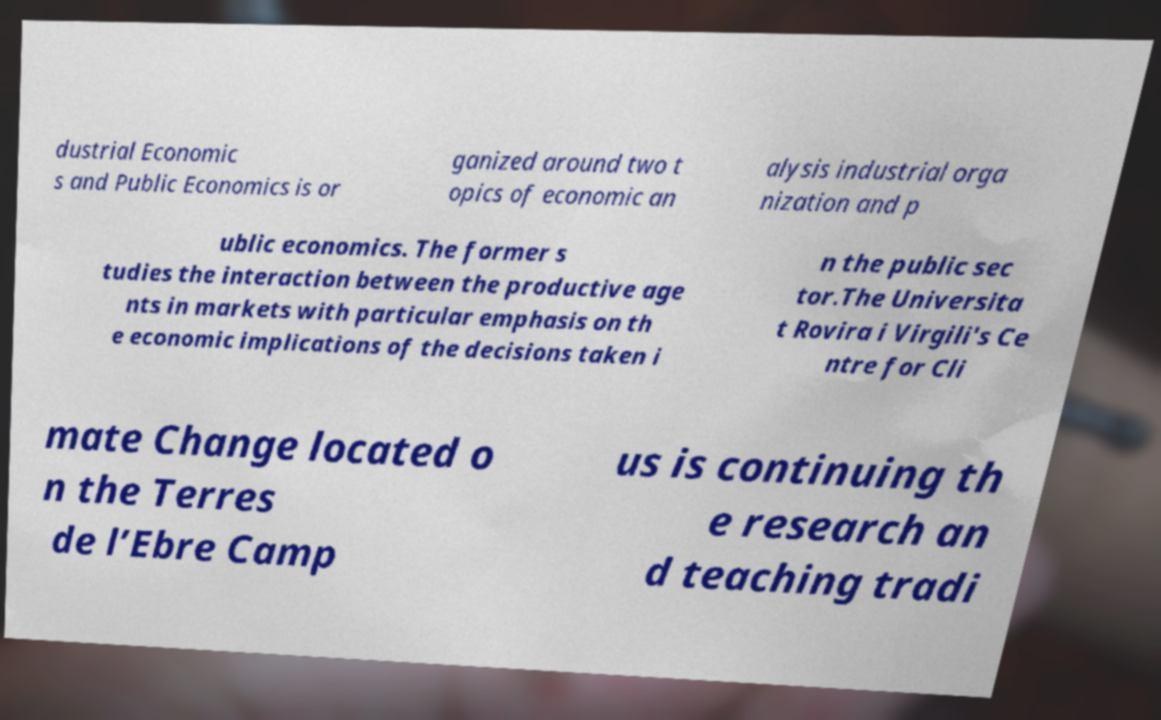There's text embedded in this image that I need extracted. Can you transcribe it verbatim? dustrial Economic s and Public Economics is or ganized around two t opics of economic an alysis industrial orga nization and p ublic economics. The former s tudies the interaction between the productive age nts in markets with particular emphasis on th e economic implications of the decisions taken i n the public sec tor.The Universita t Rovira i Virgili's Ce ntre for Cli mate Change located o n the Terres de l’Ebre Camp us is continuing th e research an d teaching tradi 